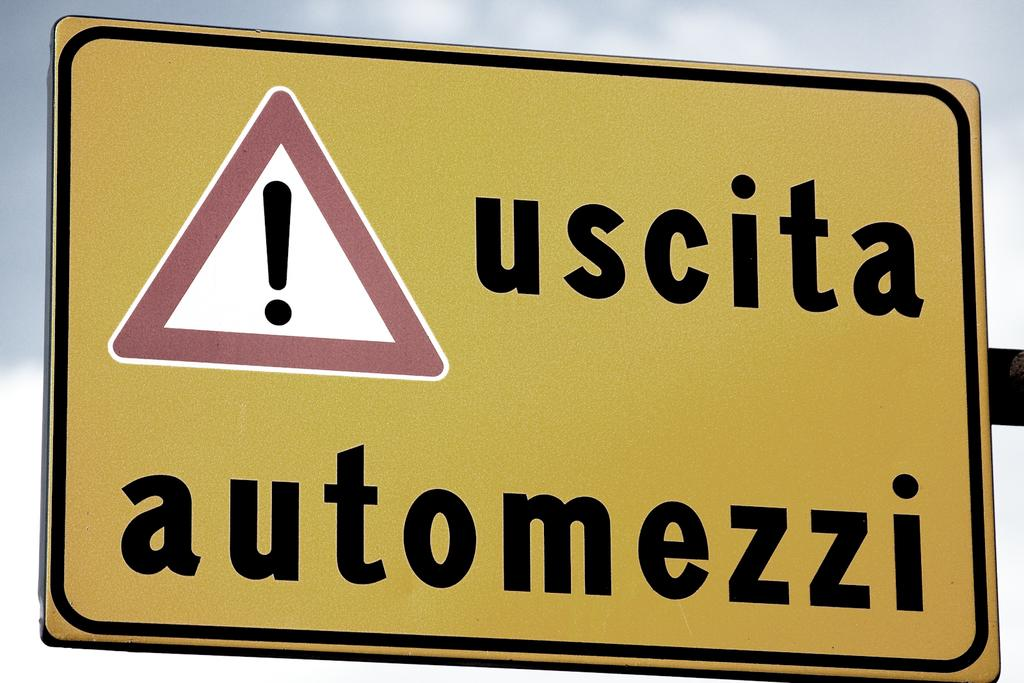<image>
Create a compact narrative representing the image presented. A yellow sign says uscita automezzi and has an exclamation point inside a triangle. 